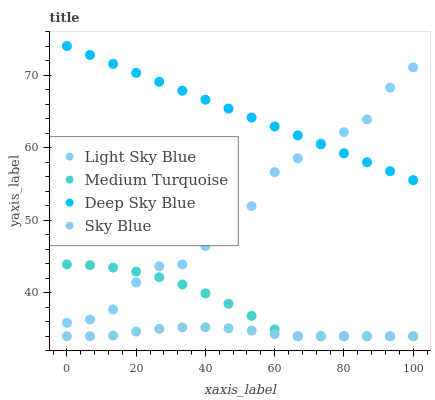Does Sky Blue have the minimum area under the curve?
Answer yes or no. Yes. Does Deep Sky Blue have the maximum area under the curve?
Answer yes or no. Yes. Does Light Sky Blue have the minimum area under the curve?
Answer yes or no. No. Does Light Sky Blue have the maximum area under the curve?
Answer yes or no. No. Is Deep Sky Blue the smoothest?
Answer yes or no. Yes. Is Light Sky Blue the roughest?
Answer yes or no. Yes. Is Light Sky Blue the smoothest?
Answer yes or no. No. Is Deep Sky Blue the roughest?
Answer yes or no. No. Does Sky Blue have the lowest value?
Answer yes or no. Yes. Does Light Sky Blue have the lowest value?
Answer yes or no. No. Does Deep Sky Blue have the highest value?
Answer yes or no. Yes. Does Light Sky Blue have the highest value?
Answer yes or no. No. Is Medium Turquoise less than Deep Sky Blue?
Answer yes or no. Yes. Is Deep Sky Blue greater than Sky Blue?
Answer yes or no. Yes. Does Sky Blue intersect Medium Turquoise?
Answer yes or no. Yes. Is Sky Blue less than Medium Turquoise?
Answer yes or no. No. Is Sky Blue greater than Medium Turquoise?
Answer yes or no. No. Does Medium Turquoise intersect Deep Sky Blue?
Answer yes or no. No. 